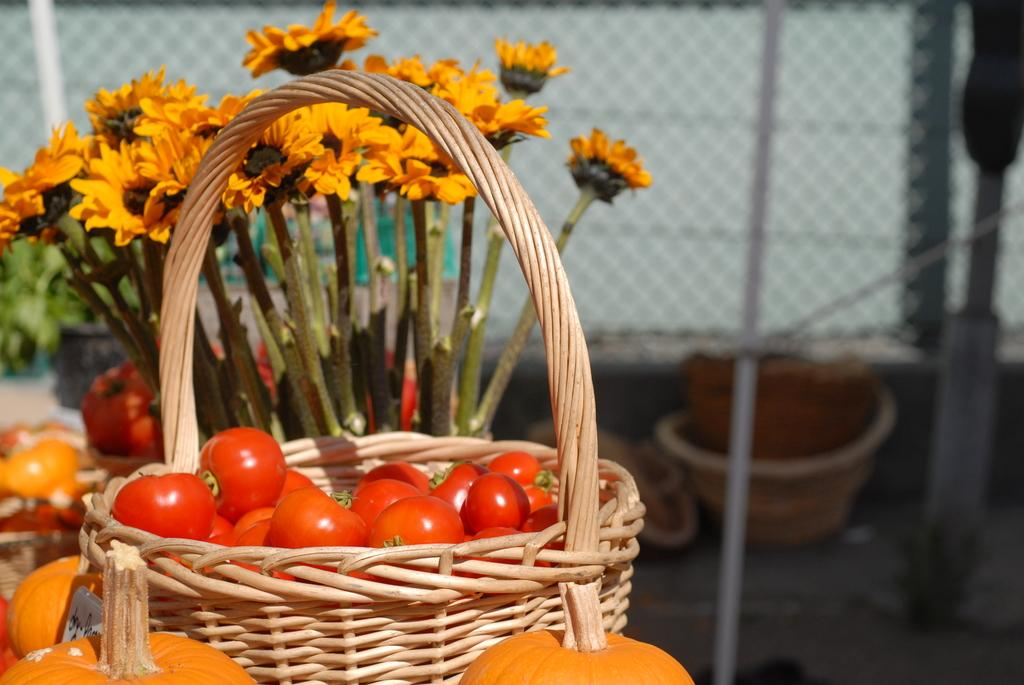What is in the basket that is visible in the image? There is a basket of tomatoes in the image. What other types of produce can be seen in the image? There are pumpkins visible in the image. What type of plants are also present in the image? There are flowers in the image. What can be seen in the background of the image? There is a wire fence and other objects visible in the background of the image. What type of feather can be seen falling on the pumpkins in the image? There is no feather present in the image; it only features tomatoes, pumpkins, flowers, a wire fence, and other objects in the background. 